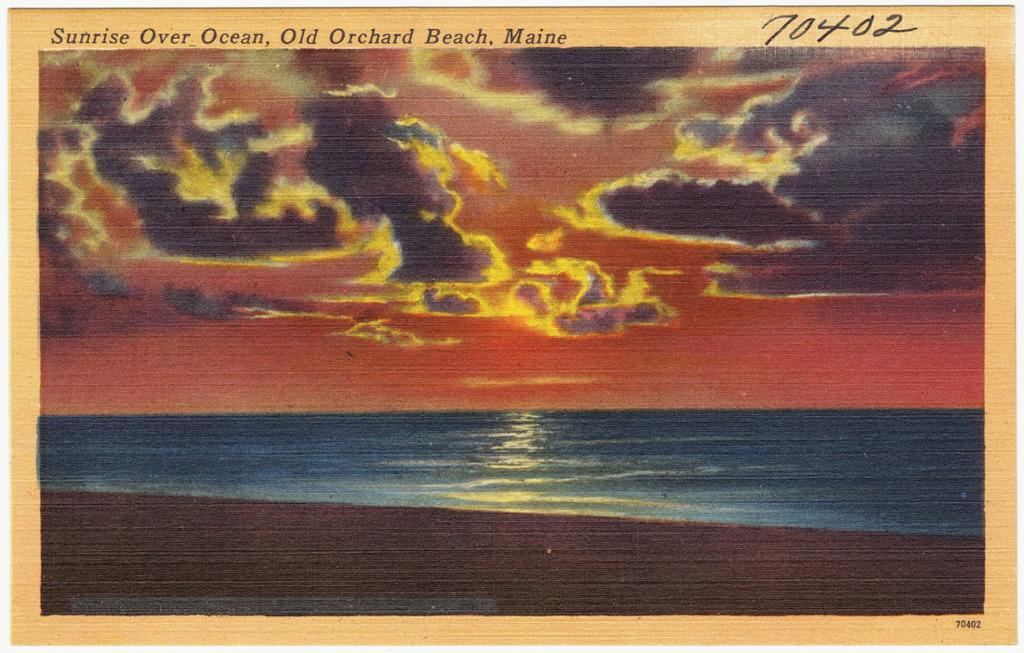<image>
Offer a succinct explanation of the picture presented. The sunrise is shown over the ocean from an Orchard in Maine. 